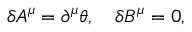Convert formula to latex. <formula><loc_0><loc_0><loc_500><loc_500>\delta A ^ { \mu } = \partial ^ { \mu } \theta , \quad \delta B ^ { \mu } = 0 ,</formula> 